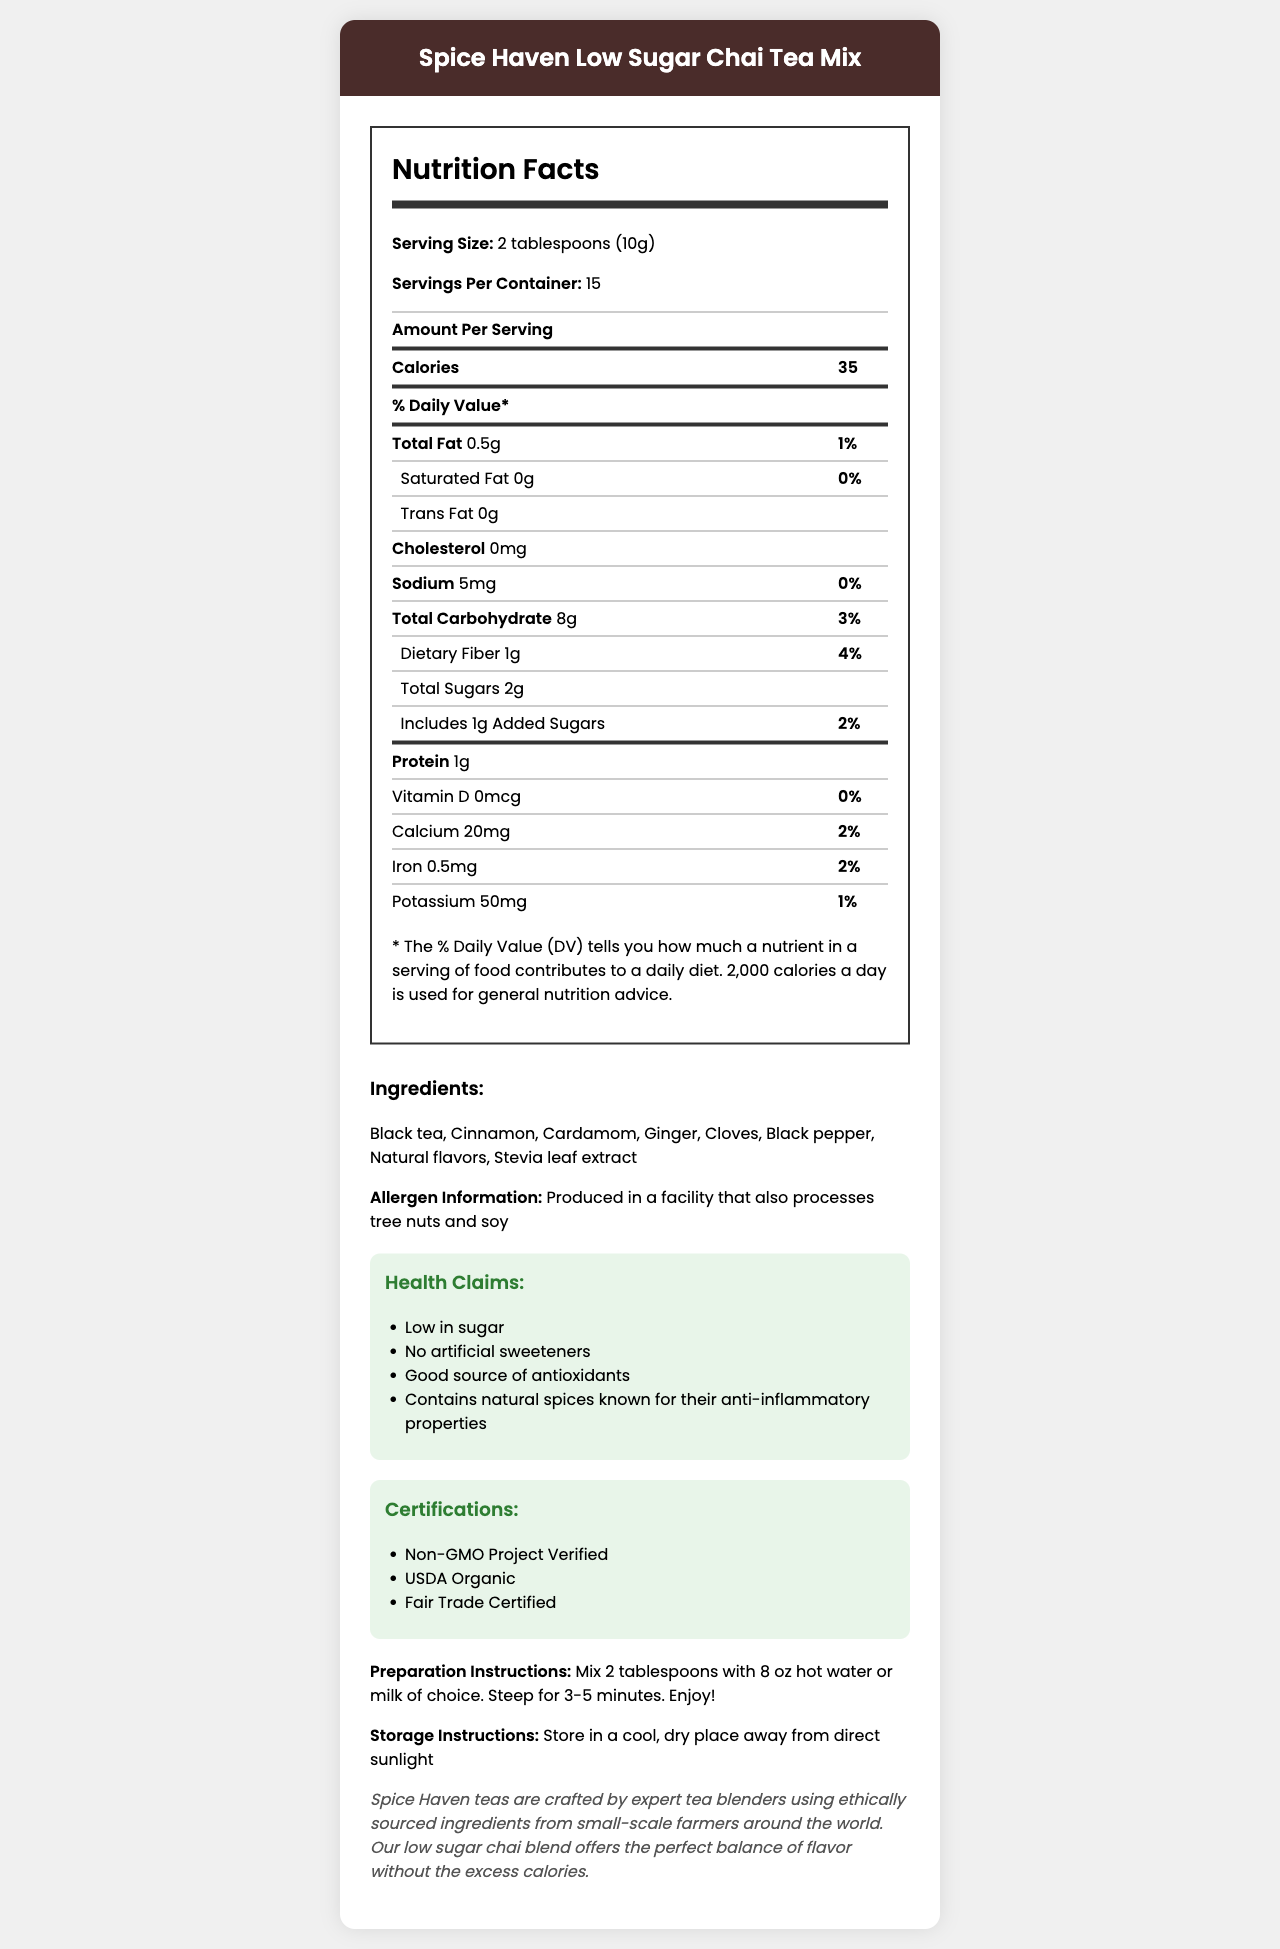What is the serving size for the Spice Haven Low Sugar Chai Tea Mix? The serving size is explicitly mentioned as "2 tablespoons (10g)" in the document.
Answer: 2 tablespoons (10g) How many servings are in a container of this chai tea mix? The document lists the number of servings per container as 15.
Answer: 15 What is the total amount of fat per serving? Under the nutrition facts, it states "Total Fat 0.5g".
Answer: 0.5g How much calcium is in one serving? The document details the calcium content as "Calcium 20mg".
Answer: 20mg Which natural spices are included in the ingredients? The ingredients list these specific spices: "Cinnamon, Cardamom, Ginger, Cloves, Black pepper".
Answer: Cinnamon, Cardamom, Ginger, Cloves, Black pepper How many grams of protein does each serving contain? A. 0g B. 1g C. 2g D. 3g The nutrition facts point out that there is "Protein 1g" per serving.
Answer: B What is the daily value percentage of dietary fiber in one serving? A. 1% B. 2% C. 3% D. 4% According to the nutrition facts, the daily value of dietary fiber is "4%".
Answer: D Does the chai tea mix contain any trans fat? It is specified as "Trans Fat 0g" in the nutrition facts.
Answer: No Is the chai tea mix free from artificial sweeteners? The health claims section states "No artificial sweeteners".
Answer: Yes What certifications does the Spice Haven chai tea mix have? The certifications section outlines these specific certifications.
Answer: Non-GMO Project Verified, USDA Organic, Fair Trade Certified Describe the main idea of the document. The explanation captures all key sections presented in the document, summarizing the focus on nutrition, ingredients, and ethical sourcing.
Answer: The document provides comprehensive information about the Spice Haven Low Sugar Chai Tea Mix, including nutrition facts, ingredients, allergen information, health claims, certifications, preparation, storage instructions, and the brand story. It emphasizes the product's low sugar content, natural spice ingredients, and certifications like Non-GMO, organic, and fair trade. What is the daily value percentage of cholesterol per serving? The document indicates "Cholesterol 0mg" which implies a 0% daily value.
Answer: 0% How many grams of added sugars are in one serving? The nutrition facts denote the added sugars amount as "Includes 1g Added Sugars".
Answer: 1g Can you determine the exact origin of the tea ingredients? The document mentions ingredients are ethically sourced from small-scale farmers around the world but does not specify exact origins.
Answer: Not enough information What type of facility produces this chai tea mix in regards to allergens? The allergen information states "Produced in a facility that also processes tree nuts and soy".
Answer: A facility that processes tree nuts and soy 